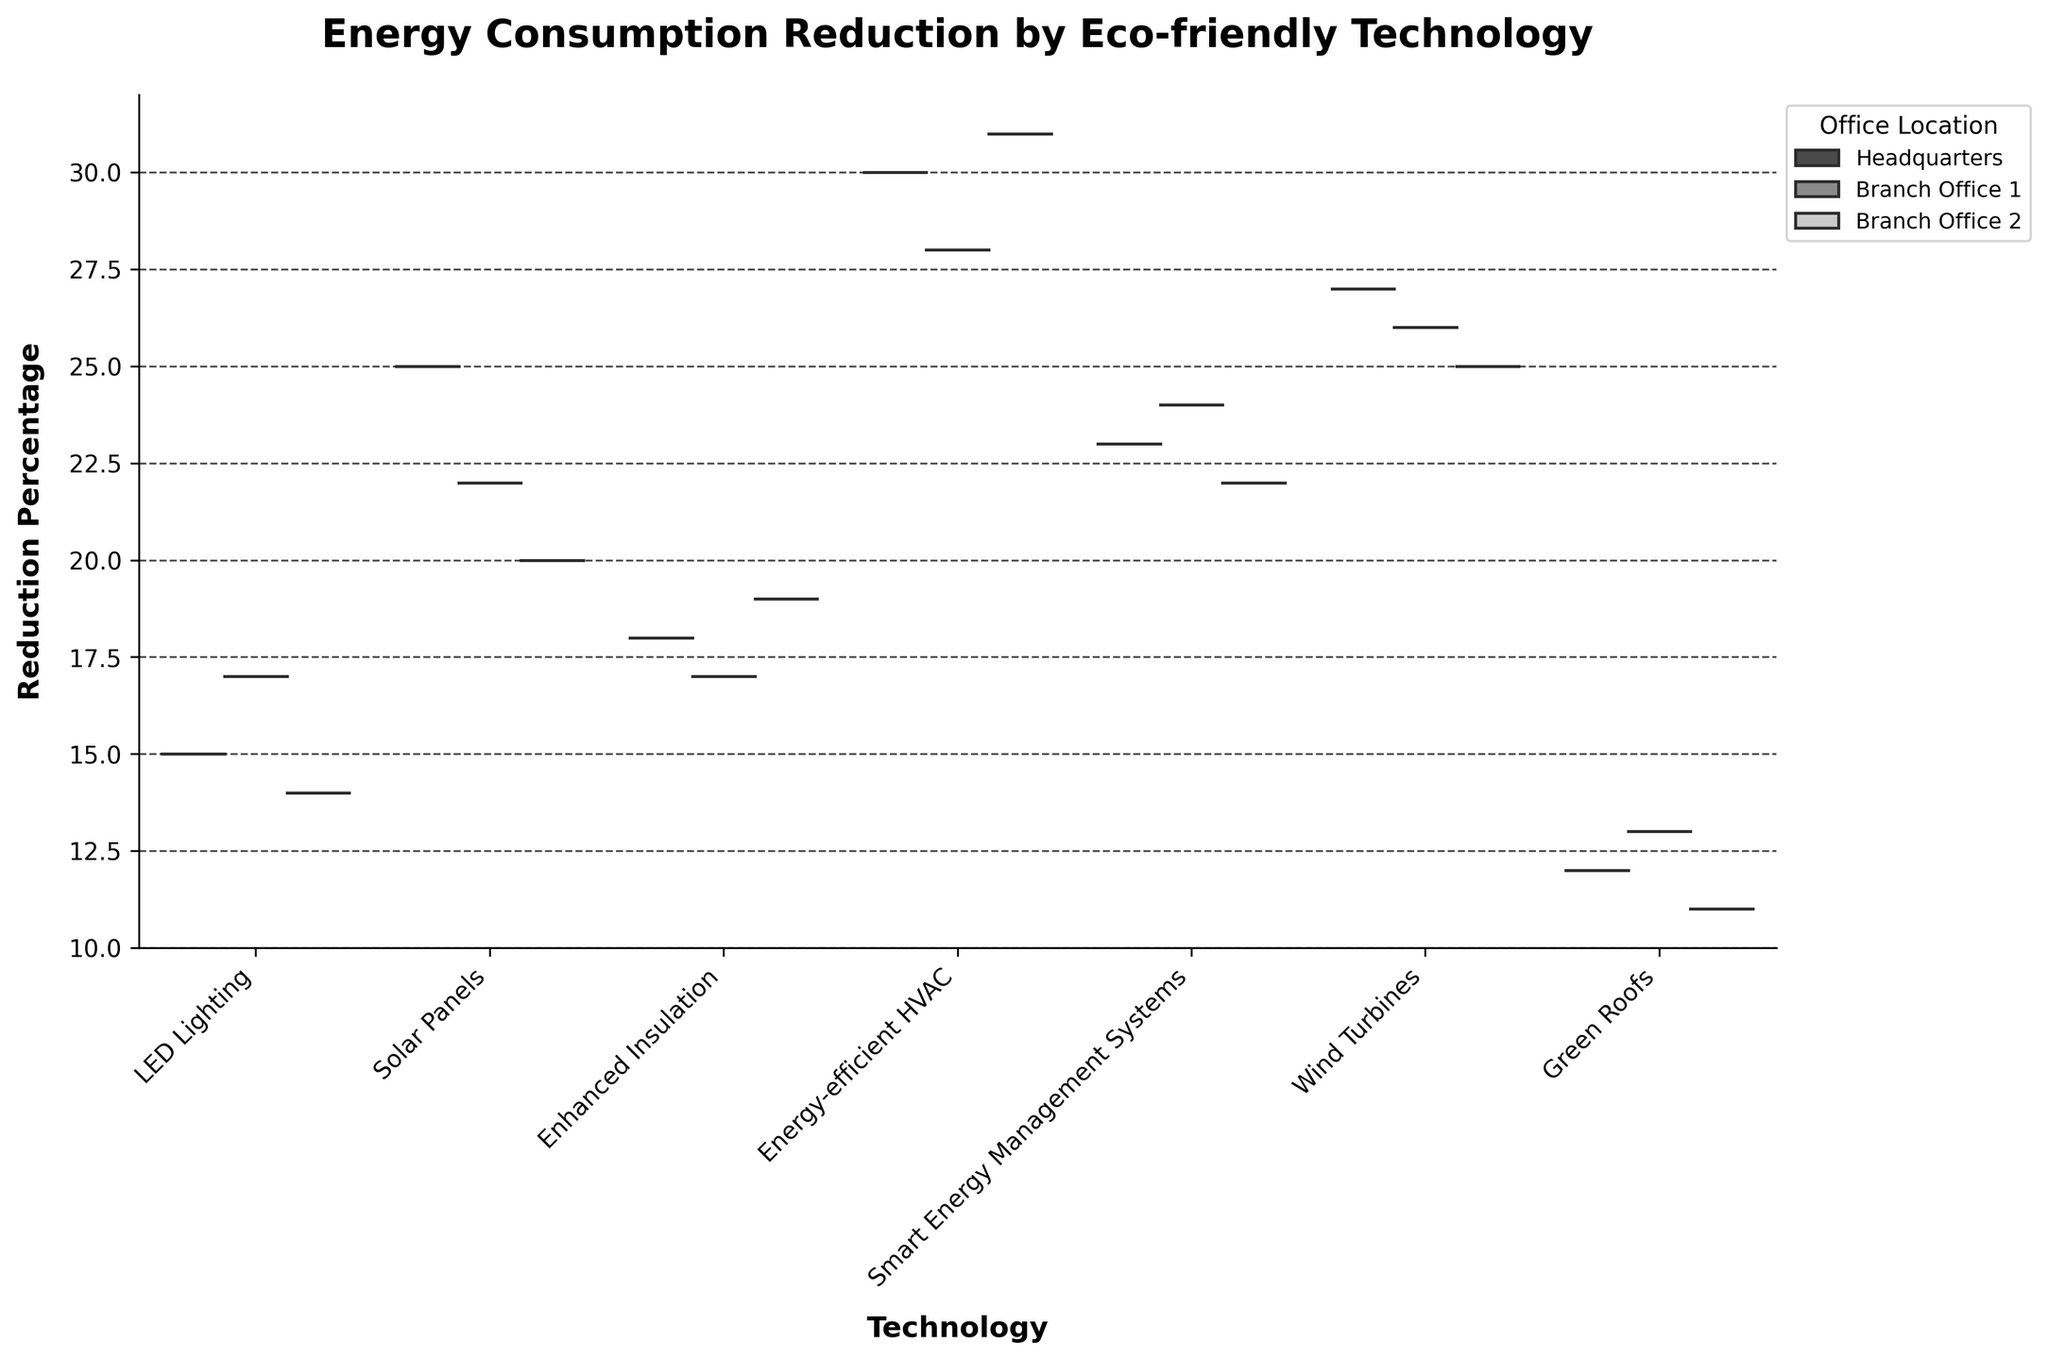What is the title of the figure? Look at the top of the figure where the title is displayed. The information there describes what the figure is about.
Answer: Energy Consumption Reduction by Eco-friendly Technology Which technology shows the highest reduction in energy consumption across all office locations? Look for the technology with the highest median value within the split violin plots across all locations.
Answer: Energy-efficient HVAC How does the reduction percentage for Green Roofs compare between Headquarters and Branch Office 2? Look at the Green Roofs category and compare the two split halves corresponding to Headquarters and Branch Office 2.
Answer: Headquarters shows 12%, whereas Branch Office 2 shows 11% What's the average reduction percentage for LED Lighting across all office locations? Identify the reduction percentages for LED Lighting (15, 17, 14) across all locations and calculate their average. Calculation: (15 + 17 + 14) / 3 = 46 / 3 ≈ 15.33
Answer: 15.33 Which office location shows the most consistent reduction percentages across different technologies? Determine which location's violin plots have the least spread across all technologies, indicating consistency.
Answer: Headquarters Does Solar Panels or Wind Turbines show greater overall reduction in energy consumption on average? Compare the median reduction percentages for Solar Panels (25, 22, 20) and Wind Turbines (27, 26, 25). Calculate the average for both: Solar Panels = (25 + 22 + 20) / 3 ≈ 22.33, Wind Turbines = (27 + 26 + 25) / 3 ≈ 26
Answer: Wind Turbines What is the range of reduction percentages for Enhanced Insulation at Headquarters? Look at the Enhanced Insulation category for Headquarters and identify the spread of the data around the median.
Answer: The range is from 17% to 19% How do Smart Energy Management Systems perform in Branch Office 1 compared to Branch Office 2? Compare the Smart Energy Management Systems category between Branch Office 1 and Branch Office 2 for their reduction percentages.
Answer: Branch Office 1 is at 24%, while Branch Office 2 is at 22% Which technology shows the minimum reduction in energy consumption at Branch Office 2? Look for the technology in Branch Office 2 with the lowest median value in its split violin plot.
Answer: Green Roofs What's the difference in energy reduction percentage between Headquarters and Branch Office 1 for Wind Turbines? Subtract the reduction percentage at Branch Office 1 from Headquarters for Wind Turbines (27% - 26% = 1%).
Answer: 1% 